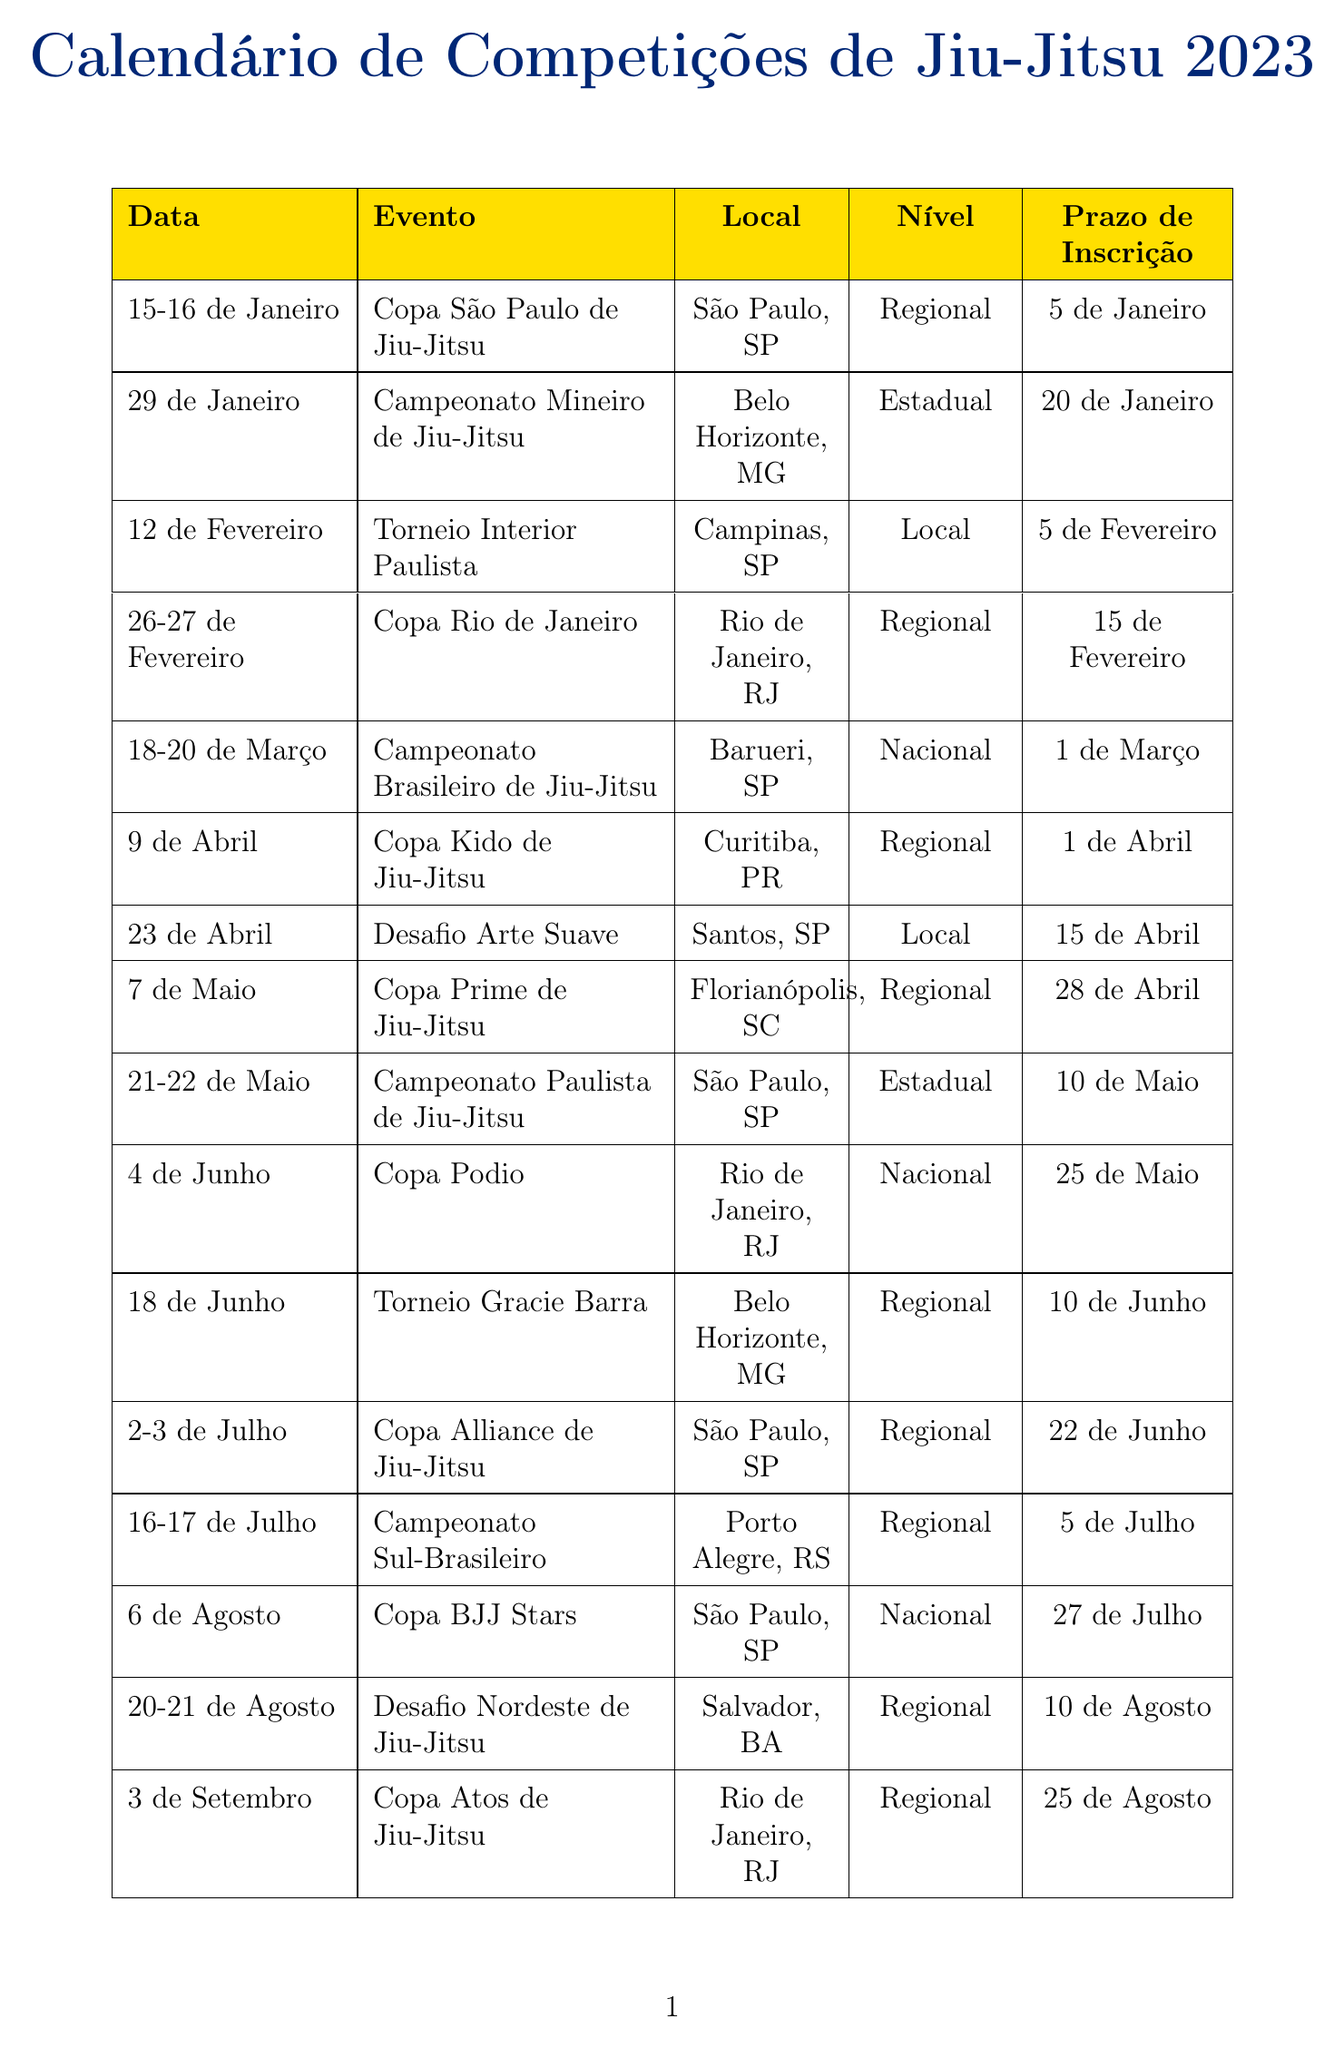What event takes place on January 29? The document lists the events for January and specifies that on January 29, the "Campeonato Mineiro de Jiu-Jitsu" will take place.
Answer: Campeonato Mineiro de Jiu-Jitsu What is the registration deadline for the Copa São Paulo de Jiu-Jitsu? The registration deadline for this event is stated in the document as January 5.
Answer: January 5 Which month has the event "Desafio Nordeste de Jiu-Jitsu"? The document indicates that "Desafio Nordeste de Jiu-Jitsu" occurs in August.
Answer: August How many regional tournaments are scheduled in July? By reviewing the events in July, it can be concluded that there are two regional tournaments: "Copa Alliance de Jiu-Jitsu" and "Campeonato Sul-Brasileiro."
Answer: 2 Where is the Campeonato Brasileiro de Jiu-Jitsu held? The location for this event is listed as Barueri, SP in the document.
Answer: Barueri, SP What is the date range for the Copa Hélio Gracie? The document states that the Copa Hélio Gracie takes place from November 5 to November 6.
Answer: November 5-6 How many events are listed in December? The document shows that there are two events scheduled in December: "Copa Dezembro de Jiu-Jitsu" and "Desafio de Verão."
Answer: 2 What is the location for the event that takes place on April 23? On April 23, the event "Desafio Arte Suave" occurs, and the location is specified as Santos, SP.
Answer: Santos, SP What is the highest level of competition listed in the calendar? The highest level according to the document is "National," which is associated with several events.
Answer: National 